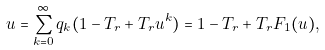<formula> <loc_0><loc_0><loc_500><loc_500>u = \sum _ { k = 0 } ^ { \infty } q _ { k } ( 1 - T _ { r } + T _ { r } u ^ { k } ) = 1 - T _ { r } + T _ { r } F _ { 1 } ( u ) ,</formula> 